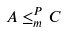<formula> <loc_0><loc_0><loc_500><loc_500>A \leq _ { m } ^ { P } C</formula> 